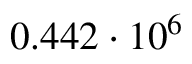Convert formula to latex. <formula><loc_0><loc_0><loc_500><loc_500>0 . 4 4 2 \cdot 1 0 ^ { 6 }</formula> 